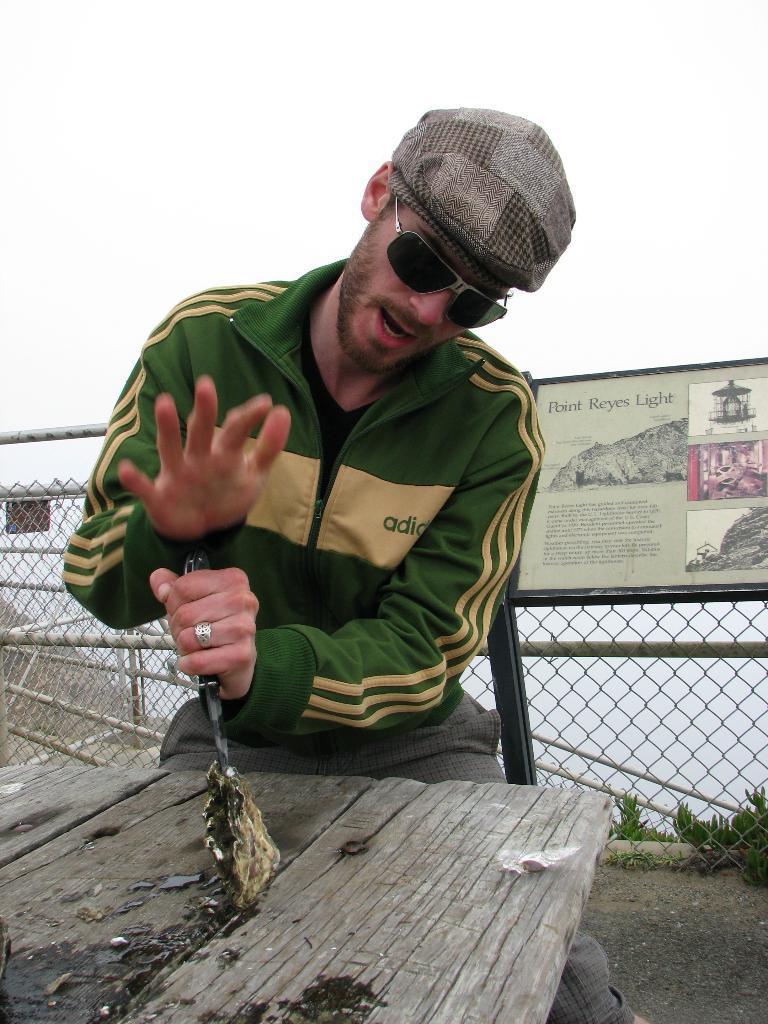Describe this image in one or two sentences. In this image there is a person holding some object. In front of him there is a wooden table. Behind him there is a photo frame. There is a wooden fence. There are plants. At the top of the image there is sky. 